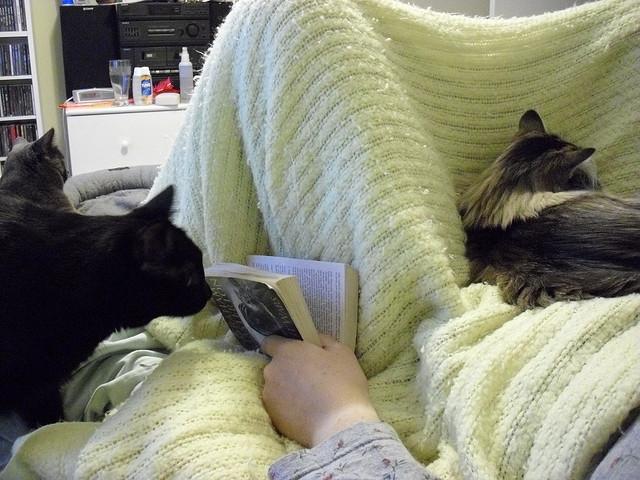Is the person actually reading the book?
Quick response, please. No. How many cats are there?
Write a very short answer. 3. Is the person reading?
Write a very short answer. Yes. 